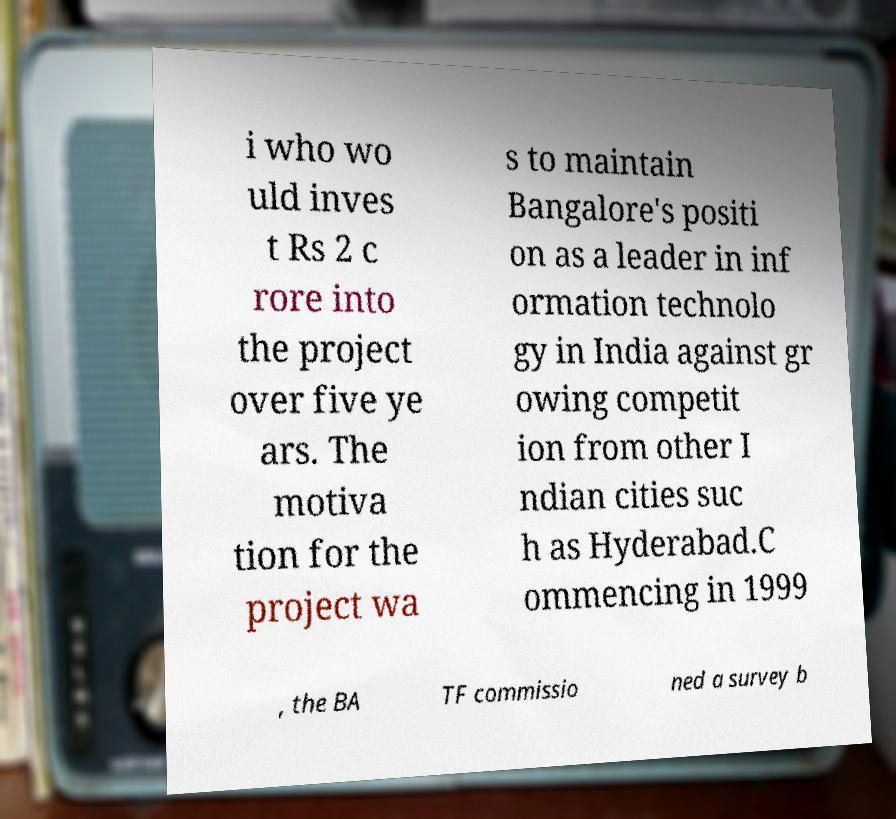I need the written content from this picture converted into text. Can you do that? i who wo uld inves t Rs 2 c rore into the project over five ye ars. The motiva tion for the project wa s to maintain Bangalore's positi on as a leader in inf ormation technolo gy in India against gr owing competit ion from other I ndian cities suc h as Hyderabad.C ommencing in 1999 , the BA TF commissio ned a survey b 